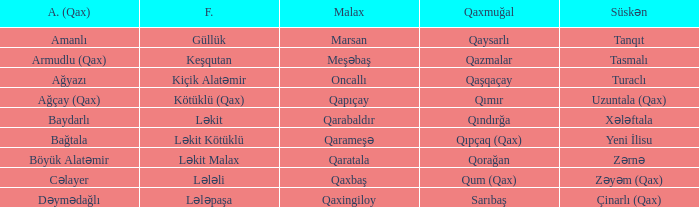What is the Qaxmuğal village with a Fistiqli village keşqutan? Qazmalar. 